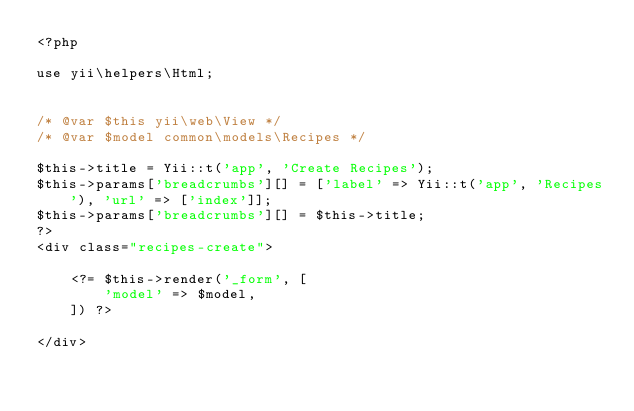Convert code to text. <code><loc_0><loc_0><loc_500><loc_500><_PHP_><?php

use yii\helpers\Html;


/* @var $this yii\web\View */
/* @var $model common\models\Recipes */

$this->title = Yii::t('app', 'Create Recipes');
$this->params['breadcrumbs'][] = ['label' => Yii::t('app', 'Recipes'), 'url' => ['index']];
$this->params['breadcrumbs'][] = $this->title;
?>
<div class="recipes-create">

    <?= $this->render('_form', [
        'model' => $model,
    ]) ?>

</div>
</code> 